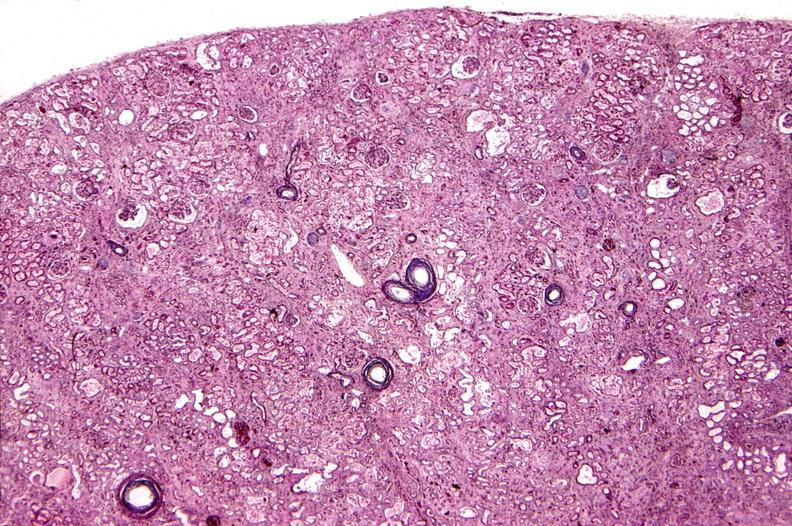what does this image show?
Answer the question using a single word or phrase. Kidney 